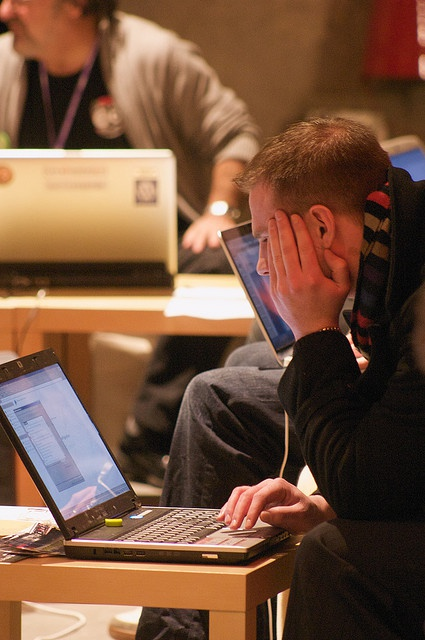Describe the objects in this image and their specific colors. I can see people in black, maroon, and brown tones, people in black, brown, maroon, and gray tones, laptop in black, tan, and olive tones, people in black and gray tones, and laptop in black, darkgray, and maroon tones in this image. 